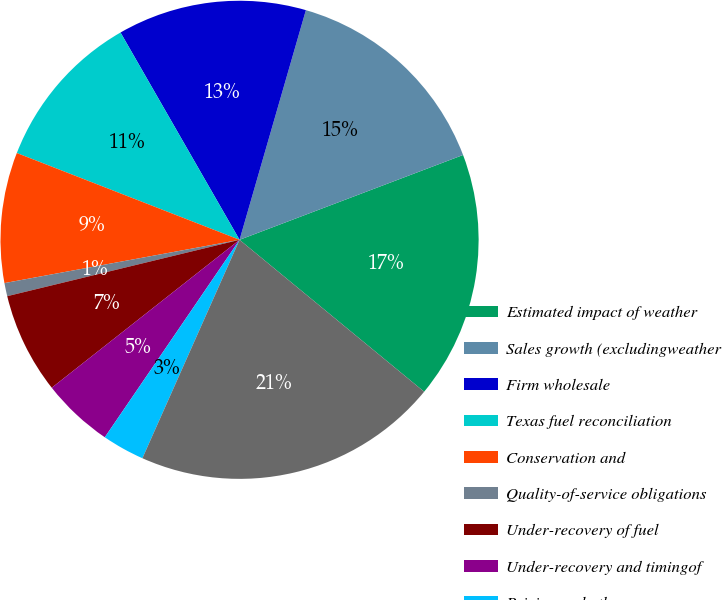Convert chart. <chart><loc_0><loc_0><loc_500><loc_500><pie_chart><fcel>Estimated impact of weather<fcel>Sales growth (excludingweather<fcel>Firm wholesale<fcel>Texas fuel reconciliation<fcel>Conservation and<fcel>Quality-of-service obligations<fcel>Under-recovery of fuel<fcel>Under-recovery and timingof<fcel>Pricing and other<fcel>Total base electric utility<nl><fcel>16.73%<fcel>14.75%<fcel>12.77%<fcel>10.79%<fcel>8.81%<fcel>0.89%<fcel>6.83%<fcel>4.85%<fcel>2.87%<fcel>20.7%<nl></chart> 